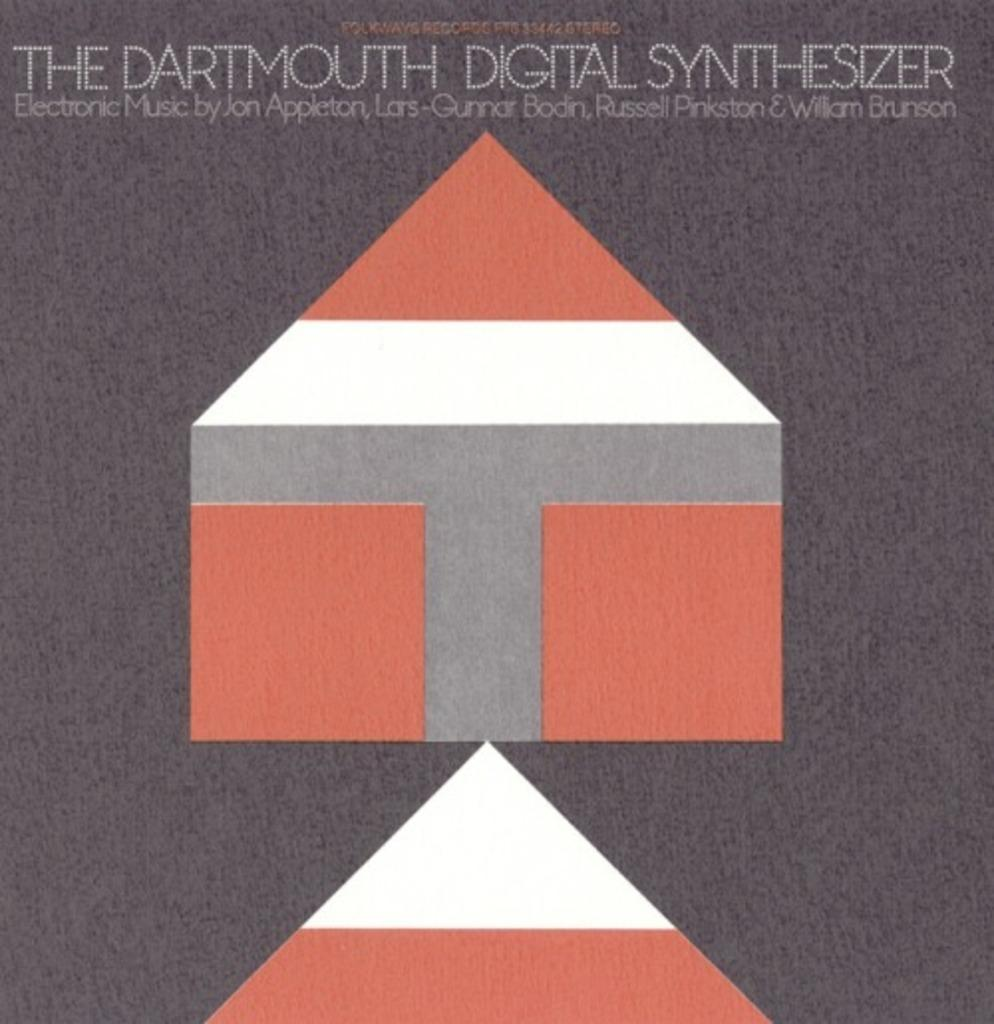<image>
Provide a brief description of the given image. Poster which shows a shape of a house and says "The Dartmouth Ditital Synthesizer". 